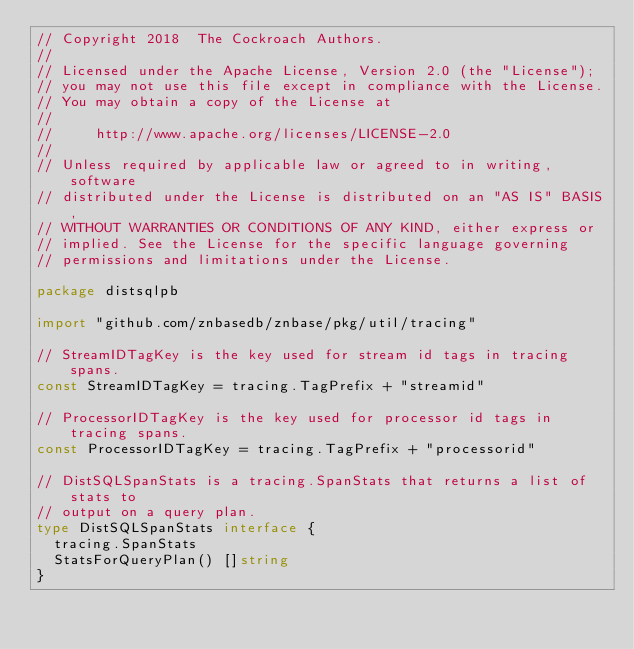<code> <loc_0><loc_0><loc_500><loc_500><_Go_>// Copyright 2018  The Cockroach Authors.
//
// Licensed under the Apache License, Version 2.0 (the "License");
// you may not use this file except in compliance with the License.
// You may obtain a copy of the License at
//
//     http://www.apache.org/licenses/LICENSE-2.0
//
// Unless required by applicable law or agreed to in writing, software
// distributed under the License is distributed on an "AS IS" BASIS,
// WITHOUT WARRANTIES OR CONDITIONS OF ANY KIND, either express or
// implied. See the License for the specific language governing
// permissions and limitations under the License.

package distsqlpb

import "github.com/znbasedb/znbase/pkg/util/tracing"

// StreamIDTagKey is the key used for stream id tags in tracing spans.
const StreamIDTagKey = tracing.TagPrefix + "streamid"

// ProcessorIDTagKey is the key used for processor id tags in tracing spans.
const ProcessorIDTagKey = tracing.TagPrefix + "processorid"

// DistSQLSpanStats is a tracing.SpanStats that returns a list of stats to
// output on a query plan.
type DistSQLSpanStats interface {
	tracing.SpanStats
	StatsForQueryPlan() []string
}
</code> 